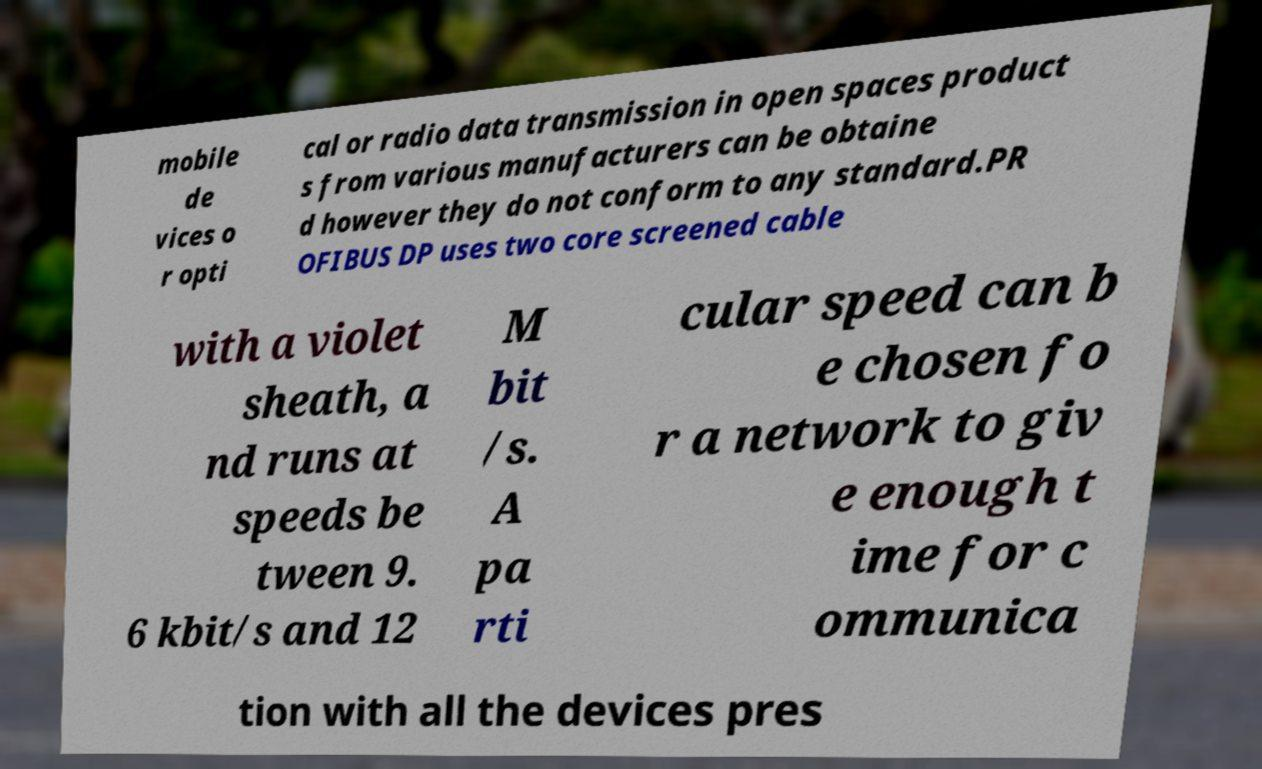There's text embedded in this image that I need extracted. Can you transcribe it verbatim? mobile de vices o r opti cal or radio data transmission in open spaces product s from various manufacturers can be obtaine d however they do not conform to any standard.PR OFIBUS DP uses two core screened cable with a violet sheath, a nd runs at speeds be tween 9. 6 kbit/s and 12 M bit /s. A pa rti cular speed can b e chosen fo r a network to giv e enough t ime for c ommunica tion with all the devices pres 